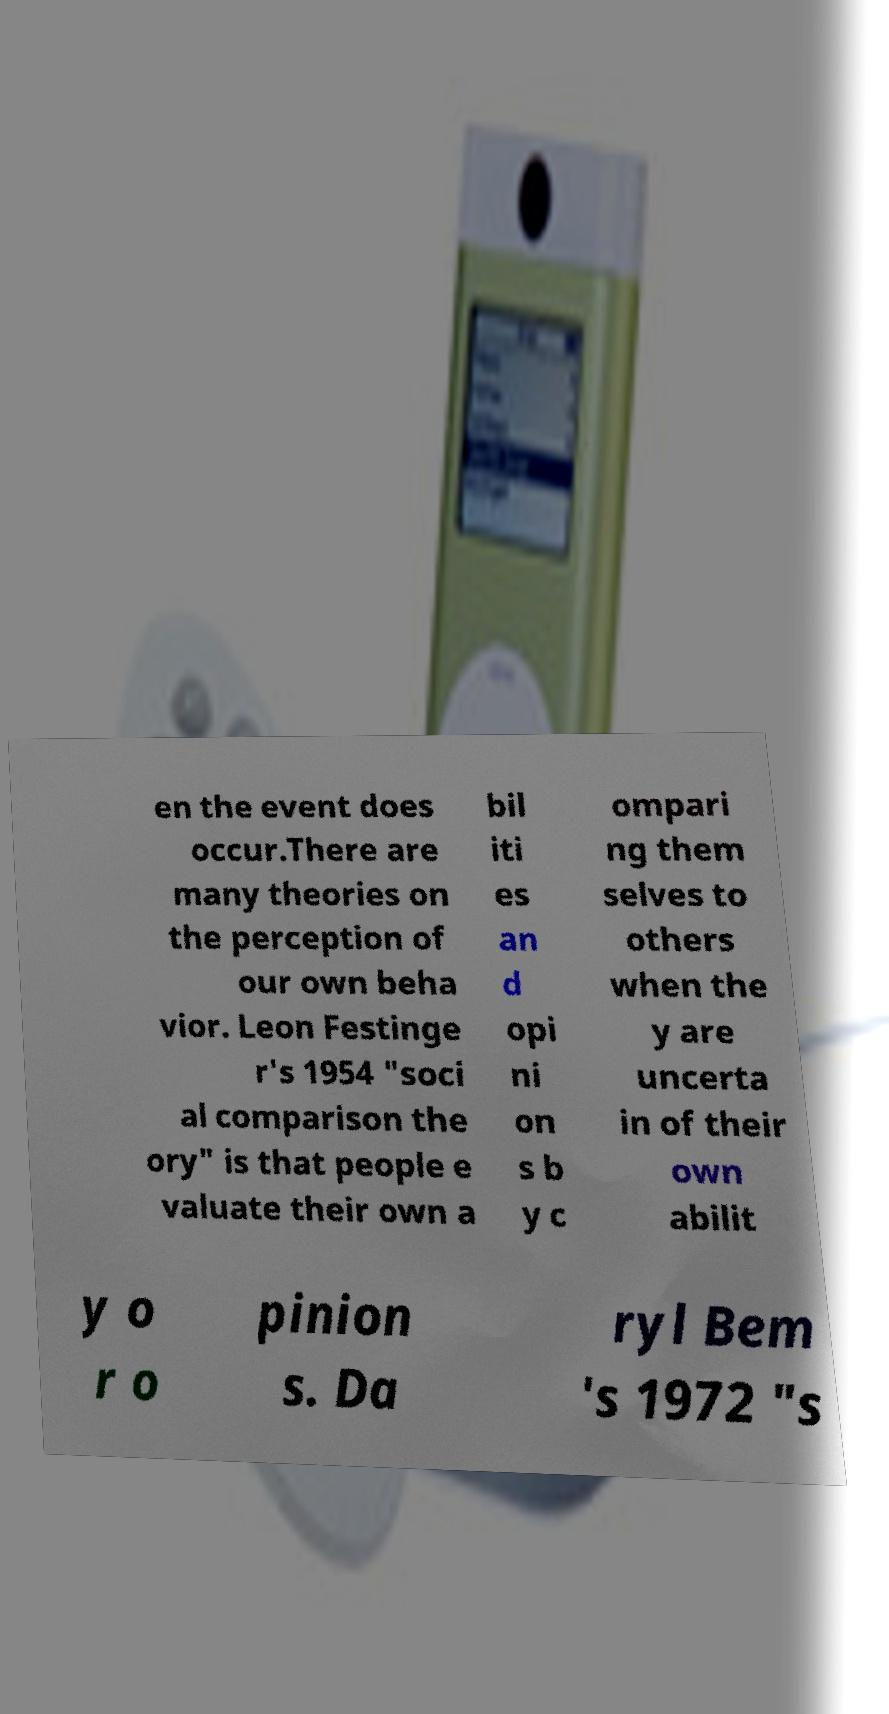There's text embedded in this image that I need extracted. Can you transcribe it verbatim? en the event does occur.There are many theories on the perception of our own beha vior. Leon Festinge r's 1954 "soci al comparison the ory" is that people e valuate their own a bil iti es an d opi ni on s b y c ompari ng them selves to others when the y are uncerta in of their own abilit y o r o pinion s. Da ryl Bem 's 1972 "s 